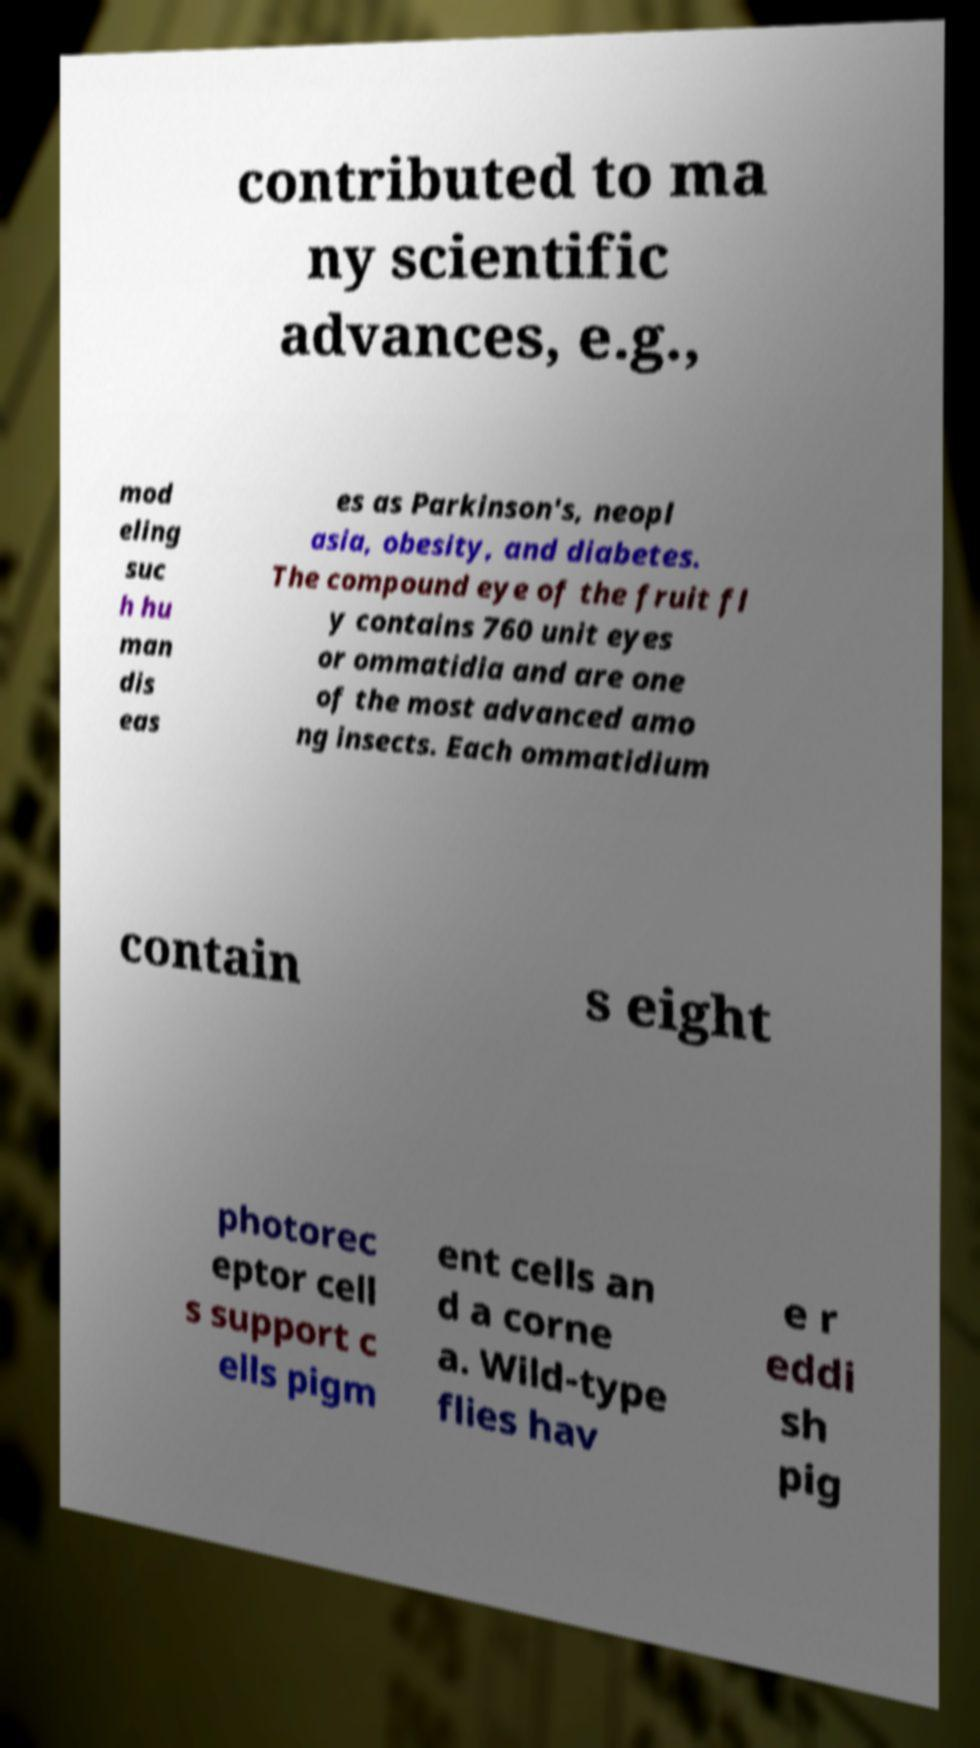Could you extract and type out the text from this image? contributed to ma ny scientific advances, e.g., mod eling suc h hu man dis eas es as Parkinson's, neopl asia, obesity, and diabetes. The compound eye of the fruit fl y contains 760 unit eyes or ommatidia and are one of the most advanced amo ng insects. Each ommatidium contain s eight photorec eptor cell s support c ells pigm ent cells an d a corne a. Wild-type flies hav e r eddi sh pig 